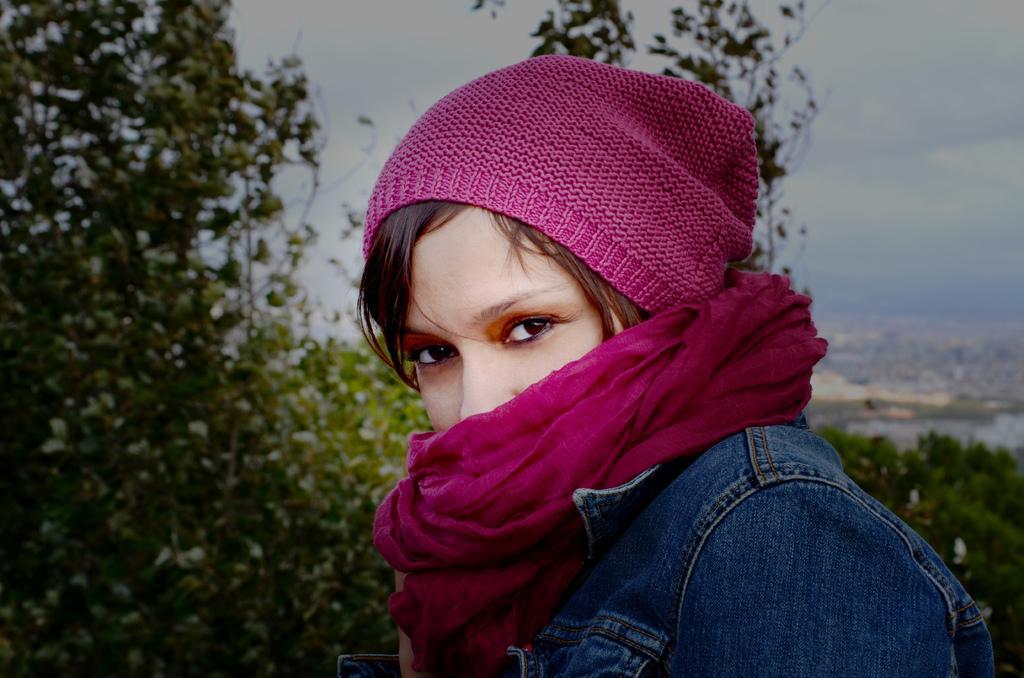In one or two sentences, can you explain what this image depicts? There is a woman wearing a scarf and a cap. In the background there are trees and sky. 